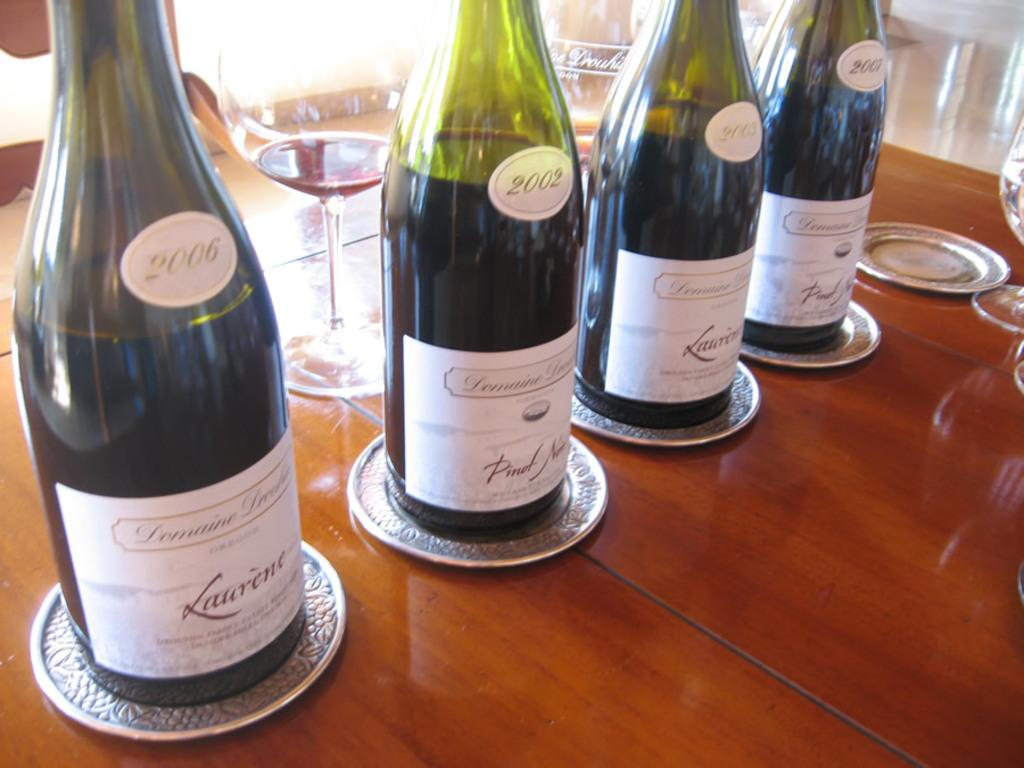What is located at the bottom of the image? There is a table at the bottom of the image. What objects are on the table? There are bottles and glasses on the table. How many dolls can be seen talking to each other on the table in the image? There are no dolls present on the table in the image. What type of voice can be heard coming from the bottles in the image? The bottles in the image are inanimate objects and do not have a voice. 